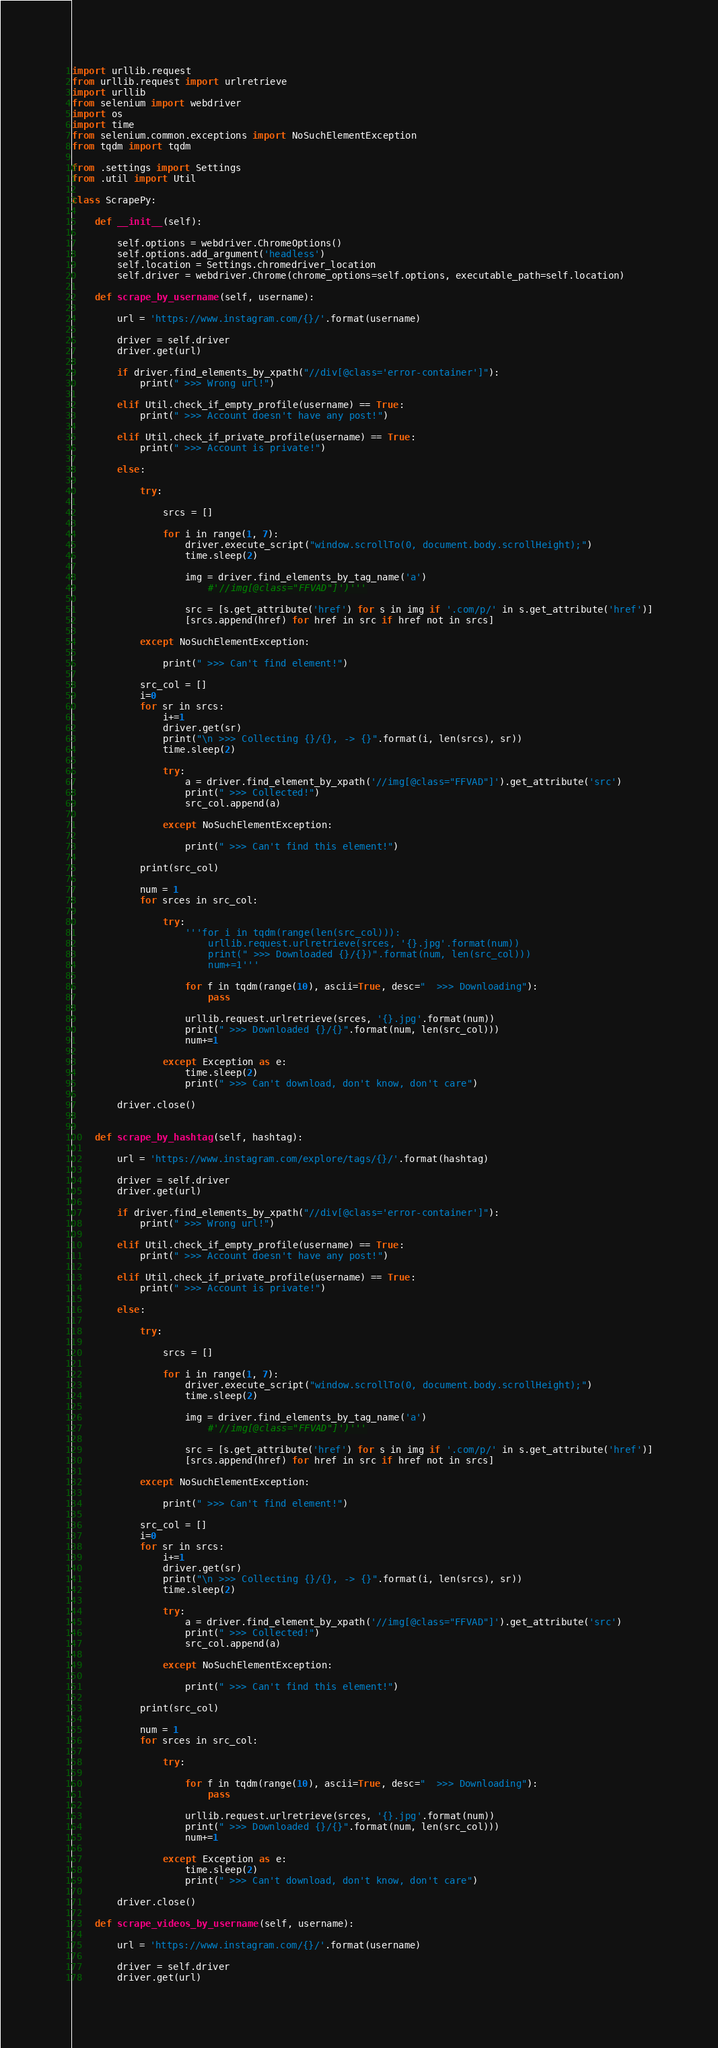Convert code to text. <code><loc_0><loc_0><loc_500><loc_500><_Python_>import urllib.request
from urllib.request import urlretrieve
import urllib
from selenium import webdriver
import os
import time
from selenium.common.exceptions import NoSuchElementException
from tqdm import tqdm

from .settings import Settings
from .util import Util

class ScrapePy:

    def __init__(self):

        self.options = webdriver.ChromeOptions()
        self.options.add_argument('headless')
        self.location = Settings.chromedriver_location
        self.driver = webdriver.Chrome(chrome_options=self.options, executable_path=self.location)

    def scrape_by_username(self, username):

        url = 'https://www.instagram.com/{}/'.format(username)

        driver = self.driver
        driver.get(url)

        if driver.find_elements_by_xpath("//div[@class='error-container']"):
            print(" >>> Wrong url!")

        elif Util.check_if_empty_profile(username) == True:
            print(" >>> Account doesn't have any post!")

        elif Util.check_if_private_profile(username) == True:
            print(" >>> Account is private!")

        else:

            try:

                srcs = []

                for i in range(1, 7):
                    driver.execute_script("window.scrollTo(0, document.body.scrollHeight);")
                    time.sleep(2)

                    img = driver.find_elements_by_tag_name('a')
                        #'//img[@class="FFVAD"]')'''

                    src = [s.get_attribute('href') for s in img if '.com/p/' in s.get_attribute('href')]
                    [srcs.append(href) for href in src if href not in srcs]

            except NoSuchElementException:

                print(" >>> Can't find element!")

            src_col = []
            i=0
            for sr in srcs:
                i+=1
                driver.get(sr)
                print("\n >>> Collecting {}/{}, -> {}".format(i, len(srcs), sr))
                time.sleep(2)

                try:
                    a = driver.find_element_by_xpath('//img[@class="FFVAD"]').get_attribute('src')
                    print(" >>> Collected!")
                    src_col.append(a)

                except NoSuchElementException:

                    print(" >>> Can't find this element!")

            print(src_col)

            num = 1
            for srces in src_col:

                try:
                    '''for i in tqdm(range(len(src_col))):
                        urllib.request.urlretrieve(srces, '{}.jpg'.format(num))
                        print(" >>> Downloaded {}/{})".format(num, len(src_col)))
                        num+=1'''

                    for f in tqdm(range(10), ascii=True, desc="  >>> Downloading"):
                        pass

                    urllib.request.urlretrieve(srces, '{}.jpg'.format(num))
                    print(" >>> Downloaded {}/{}".format(num, len(src_col)))
                    num+=1

                except Exception as e:
                    time.sleep(2)
                    print(" >>> Can't download, don't know, don't care")

        driver.close()


    def scrape_by_hashtag(self, hashtag):

        url = 'https://www.instagram.com/explore/tags/{}/'.format(hashtag)

        driver = self.driver
        driver.get(url)

        if driver.find_elements_by_xpath("//div[@class='error-container']"):
            print(" >>> Wrong url!")

        elif Util.check_if_empty_profile(username) == True:
            print(" >>> Account doesn't have any post!")

        elif Util.check_if_private_profile(username) == True:
            print(" >>> Account is private!")

        else:

            try:

                srcs = []

                for i in range(1, 7):
                    driver.execute_script("window.scrollTo(0, document.body.scrollHeight);")
                    time.sleep(2)

                    img = driver.find_elements_by_tag_name('a')
                        #'//img[@class="FFVAD"]')'''

                    src = [s.get_attribute('href') for s in img if '.com/p/' in s.get_attribute('href')]
                    [srcs.append(href) for href in src if href not in srcs]

            except NoSuchElementException:

                print(" >>> Can't find element!")

            src_col = []
            i=0
            for sr in srcs:
                i+=1
                driver.get(sr)
                print("\n >>> Collecting {}/{}, -> {}".format(i, len(srcs), sr))
                time.sleep(2)

                try:
                    a = driver.find_element_by_xpath('//img[@class="FFVAD"]').get_attribute('src')
                    print(" >>> Collected!")
                    src_col.append(a)

                except NoSuchElementException:

                    print(" >>> Can't find this element!")

            print(src_col)

            num = 1
            for srces in src_col:

                try:

                    for f in tqdm(range(10), ascii=True, desc="  >>> Downloading"):
                        pass

                    urllib.request.urlretrieve(srces, '{}.jpg'.format(num))
                    print(" >>> Downloaded {}/{}".format(num, len(src_col)))
                    num+=1

                except Exception as e:
                    time.sleep(2)
                    print(" >>> Can't download, don't know, don't care")

        driver.close()

    def scrape_videos_by_username(self, username):

        url = 'https://www.instagram.com/{}/'.format(username)

        driver = self.driver
        driver.get(url)
</code> 